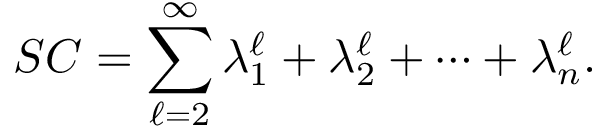Convert formula to latex. <formula><loc_0><loc_0><loc_500><loc_500>S C = \sum _ { \ell = 2 } ^ { \infty } \lambda _ { 1 } ^ { \ell } + \lambda _ { 2 } ^ { \ell } + \dots + \lambda _ { n } ^ { \ell } .</formula> 